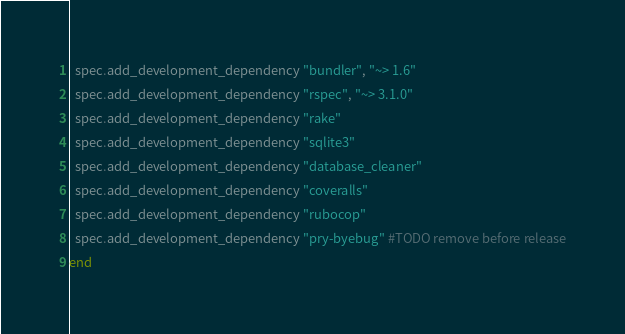<code> <loc_0><loc_0><loc_500><loc_500><_Ruby_>  spec.add_development_dependency "bundler", "~> 1.6"
  spec.add_development_dependency "rspec", "~> 3.1.0"
  spec.add_development_dependency "rake"
  spec.add_development_dependency "sqlite3"
  spec.add_development_dependency "database_cleaner"
  spec.add_development_dependency "coveralls"
  spec.add_development_dependency "rubocop"
  spec.add_development_dependency "pry-byebug" #TODO remove before release
end
</code> 